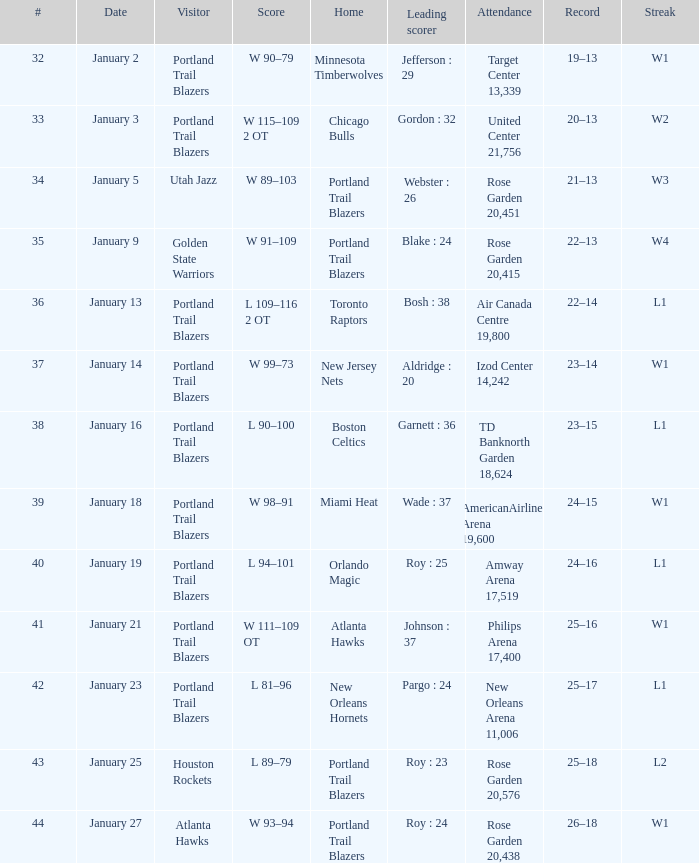Give me the full table as a dictionary. {'header': ['#', 'Date', 'Visitor', 'Score', 'Home', 'Leading scorer', 'Attendance', 'Record', 'Streak'], 'rows': [['32', 'January 2', 'Portland Trail Blazers', 'W 90–79', 'Minnesota Timberwolves', 'Jefferson : 29', 'Target Center 13,339', '19–13', 'W1'], ['33', 'January 3', 'Portland Trail Blazers', 'W 115–109 2 OT', 'Chicago Bulls', 'Gordon : 32', 'United Center 21,756', '20–13', 'W2'], ['34', 'January 5', 'Utah Jazz', 'W 89–103', 'Portland Trail Blazers', 'Webster : 26', 'Rose Garden 20,451', '21–13', 'W3'], ['35', 'January 9', 'Golden State Warriors', 'W 91–109', 'Portland Trail Blazers', 'Blake : 24', 'Rose Garden 20,415', '22–13', 'W4'], ['36', 'January 13', 'Portland Trail Blazers', 'L 109–116 2 OT', 'Toronto Raptors', 'Bosh : 38', 'Air Canada Centre 19,800', '22–14', 'L1'], ['37', 'January 14', 'Portland Trail Blazers', 'W 99–73', 'New Jersey Nets', 'Aldridge : 20', 'Izod Center 14,242', '23–14', 'W1'], ['38', 'January 16', 'Portland Trail Blazers', 'L 90–100', 'Boston Celtics', 'Garnett : 36', 'TD Banknorth Garden 18,624', '23–15', 'L1'], ['39', 'January 18', 'Portland Trail Blazers', 'W 98–91', 'Miami Heat', 'Wade : 37', 'AmericanAirlines Arena 19,600', '24–15', 'W1'], ['40', 'January 19', 'Portland Trail Blazers', 'L 94–101', 'Orlando Magic', 'Roy : 25', 'Amway Arena 17,519', '24–16', 'L1'], ['41', 'January 21', 'Portland Trail Blazers', 'W 111–109 OT', 'Atlanta Hawks', 'Johnson : 37', 'Philips Arena 17,400', '25–16', 'W1'], ['42', 'January 23', 'Portland Trail Blazers', 'L 81–96', 'New Orleans Hornets', 'Pargo : 24', 'New Orleans Arena 11,006', '25–17', 'L1'], ['43', 'January 25', 'Houston Rockets', 'L 89–79', 'Portland Trail Blazers', 'Roy : 23', 'Rose Garden 20,576', '25–18', 'L2'], ['44', 'January 27', 'Atlanta Hawks', 'W 93–94', 'Portland Trail Blazers', 'Roy : 24', 'Rose Garden 20,438', '26–18', 'W1']]} What are all the records with a score of 98-91? 24–15. 